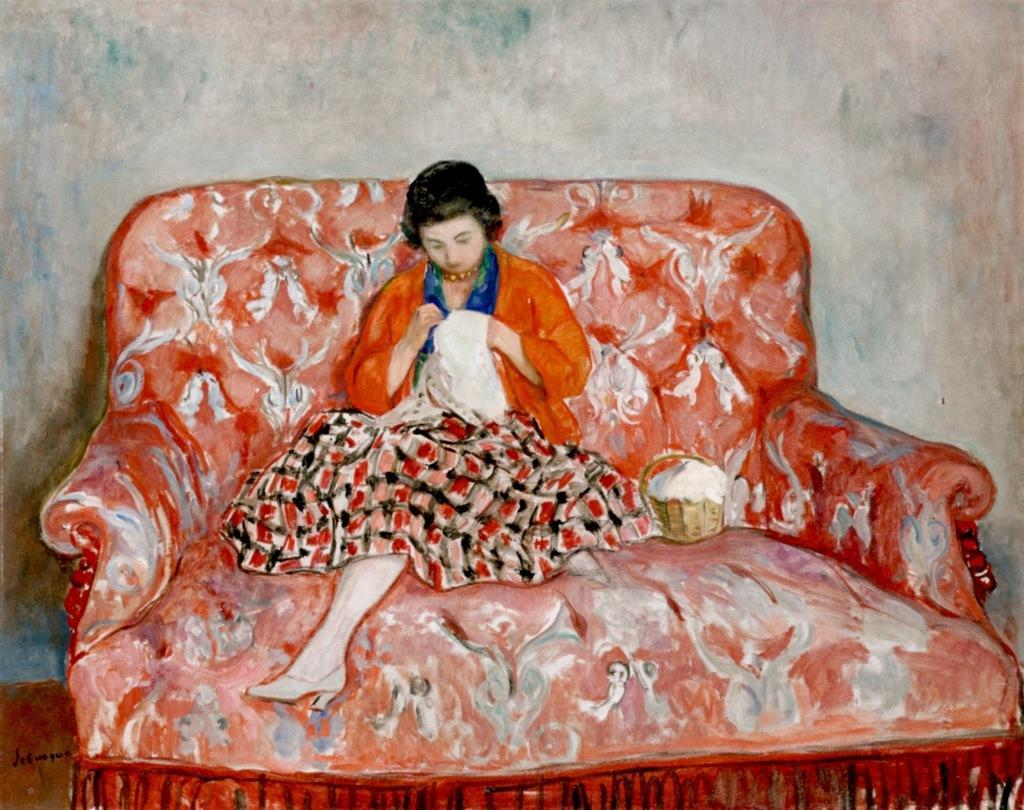Please provide a concise description of this image. This is a painting in this image there is a lady sitting on a sofa, beside her there is a box, in the background there is a wall. 